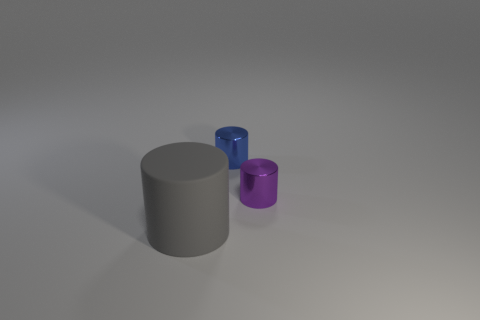Add 2 big brown spheres. How many objects exist? 5 Add 1 blue cylinders. How many blue cylinders exist? 2 Subtract 0 cyan cubes. How many objects are left? 3 Subtract all shiny things. Subtract all gray rubber cylinders. How many objects are left? 0 Add 3 matte cylinders. How many matte cylinders are left? 4 